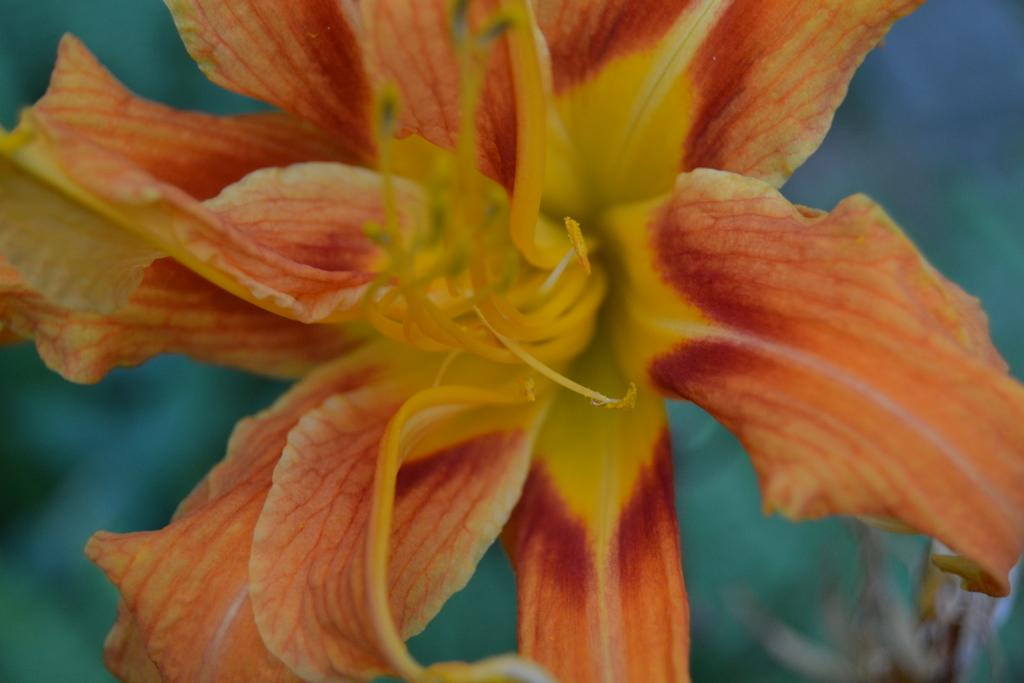What type of flower is in the picture? There is a hibiscus flower in the picture. Can you describe the background of the image? The background of the image is blurred. What day of the week is the hibiscus flower in the image? The day of the week is not mentioned or visible in the image, as it only shows a hibiscus flower and a blurred background. 